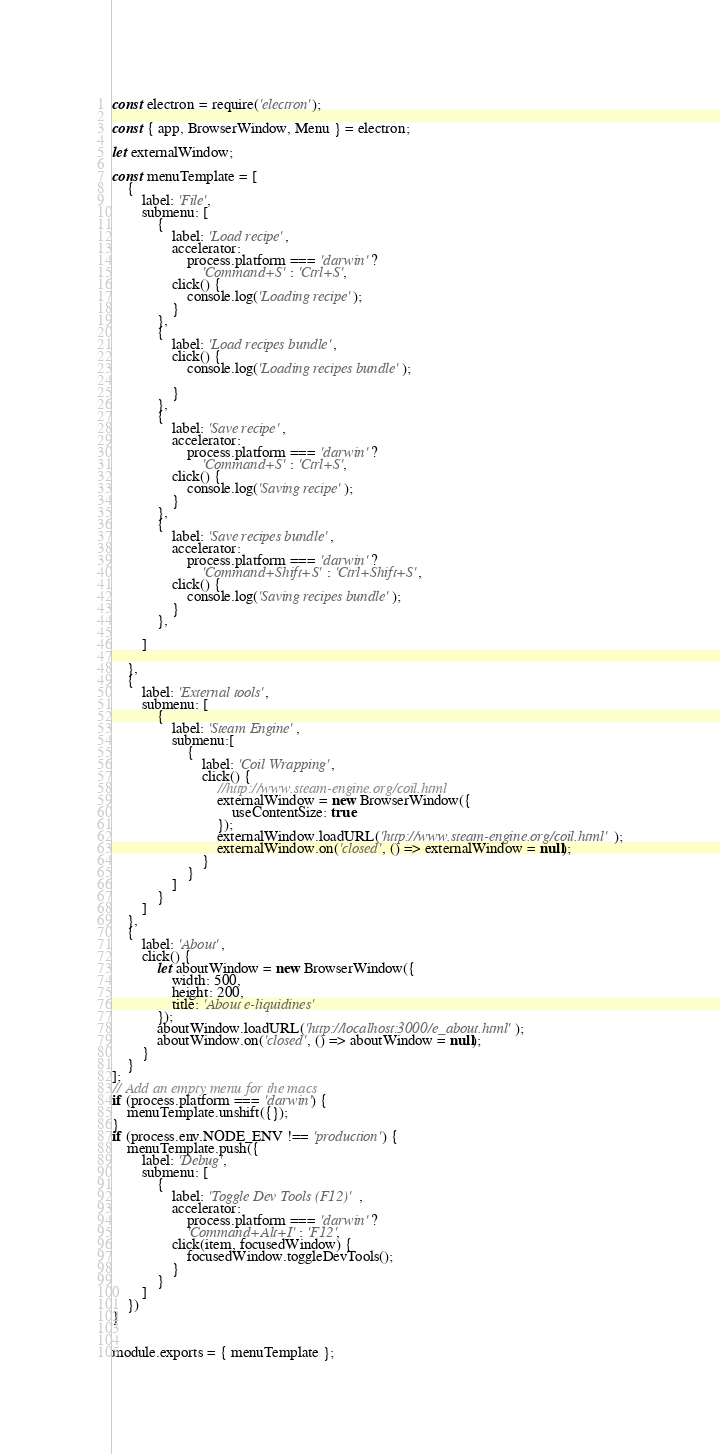<code> <loc_0><loc_0><loc_500><loc_500><_JavaScript_>const electron = require('electron');

const { app, BrowserWindow, Menu } = electron;

let externalWindow;

const menuTemplate = [
    {
        label: 'File',
        submenu: [
            {
                label: 'Load recipe',
                accelerator: 
                    process.platform === 'darwin' ?
                        'Command+S' : 'Ctrl+S',
                click() {
                    console.log('Loading recipe');
                }
            },
            {
                label: 'Load recipes bundle',
                click() {
                    console.log('Loading recipes bundle');

                }
            },
            {
                label: 'Save recipe',
                accelerator: 
                    process.platform === 'darwin' ?
                        'Command+S' : 'Ctrl+S',
                click() {
                    console.log('Saving recipe');
                }
            },
            {
                label: 'Save recipes bundle',
                accelerator: 
                    process.platform === 'darwin' ?
                        'Command+Shift+S' : 'Ctrl+Shift+S',
                click() {
                    console.log('Saving recipes bundle');
                }
            },
            
        ]   

    },
    {
        label: 'External tools',
        submenu: [
            {
                label: 'Steam Engine',
                submenu:[
                    {
                        label: 'Coil Wrapping',
                        click() {
                            //http://www.steam-engine.org/coil.html
                            externalWindow = new BrowserWindow({
                                useContentSize: true
                            });
                            externalWindow.loadURL('http://www.steam-engine.org/coil.html');
                            externalWindow.on('closed', () => externalWindow = null);
                        }
                    }
                ]
            }
        ]
    },
    {
        label: 'About',
        click() {
            let aboutWindow = new BrowserWindow({
                width: 500,
                height: 200,
                title: 'About e-liquidines'
            });
            aboutWindow.loadURL('http://localhost:3000/e_about.html');
            aboutWindow.on('closed', () => aboutWindow = null);
        }
    }
];
// Add an empty menu for the macs
if (process.platform === 'darwin') {
    menuTemplate.unshift({});
}
if (process.env.NODE_ENV !== 'production') {
    menuTemplate.push({
        label: 'Debug',
        submenu: [
            {
                label: 'Toggle Dev Tools (F12)' ,
                accelerator:  
                    process.platform === 'darwin' ?
                    'Command+Alt+I' : 'F12',
                click(item, focusedWindow) {
                    focusedWindow.toggleDevTools();
                }
            }
        ]
    })
}


module.exports = { menuTemplate };</code> 